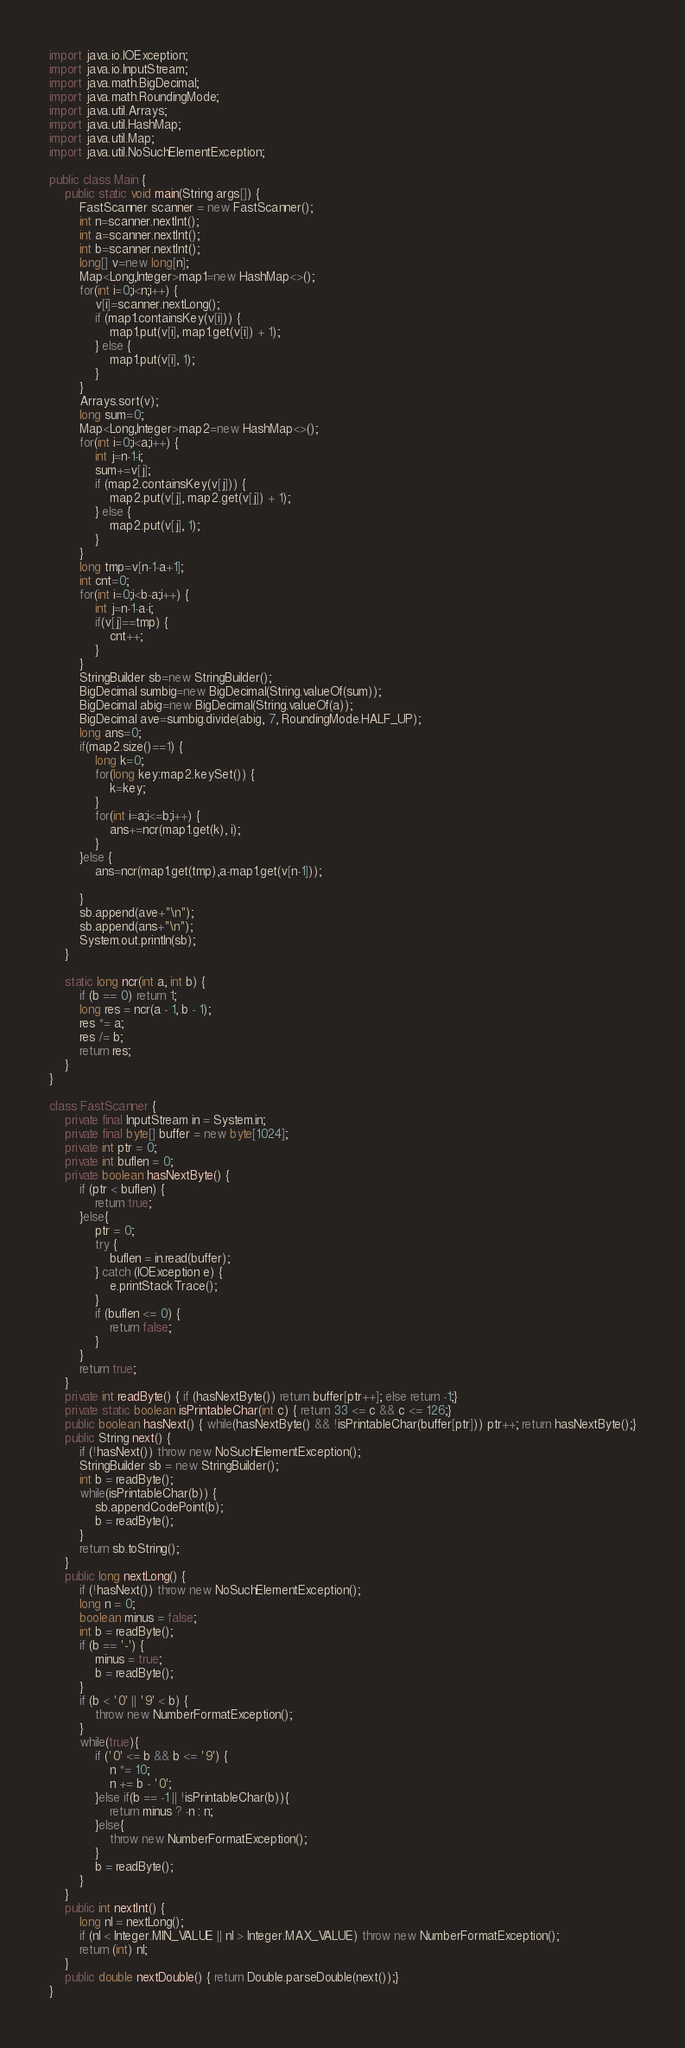<code> <loc_0><loc_0><loc_500><loc_500><_Java_>import java.io.IOException;
import java.io.InputStream;
import java.math.BigDecimal;
import java.math.RoundingMode;
import java.util.Arrays;
import java.util.HashMap;
import java.util.Map;
import java.util.NoSuchElementException;

public class Main {
	public static void main(String args[]) {
		FastScanner scanner = new FastScanner();
		int n=scanner.nextInt();
		int a=scanner.nextInt();
		int b=scanner.nextInt();
		long[] v=new long[n];
		Map<Long,Integer>map1=new HashMap<>();
		for(int i=0;i<n;i++) {
			v[i]=scanner.nextLong();
			if (map1.containsKey(v[i])) {
				map1.put(v[i], map1.get(v[i]) + 1);
			} else {
				map1.put(v[i], 1);
			}
		}
		Arrays.sort(v);
		long sum=0;
		Map<Long,Integer>map2=new HashMap<>();
		for(int i=0;i<a;i++) {
			int j=n-1-i;
			sum+=v[j];
			if (map2.containsKey(v[j])) {
				map2.put(v[j], map2.get(v[j]) + 1);
			} else {
				map2.put(v[j], 1);
			}
		}
		long tmp=v[n-1-a+1];
		int cnt=0;
		for(int i=0;i<b-a;i++) {
			int j=n-1-a-i;
			if(v[j]==tmp) {
				cnt++;
			}
		}
		StringBuilder sb=new StringBuilder();
		BigDecimal sumbig=new BigDecimal(String.valueOf(sum));
		BigDecimal abig=new BigDecimal(String.valueOf(a));
		BigDecimal ave=sumbig.divide(abig, 7, RoundingMode.HALF_UP);
		long ans=0;
		if(map2.size()==1) {
			long k=0;
			for(long key:map2.keySet()) {
				k=key;
			}
			for(int i=a;i<=b;i++) {
				ans+=ncr(map1.get(k), i);
			}
		}else {
			ans=ncr(map1.get(tmp),a-map1.get(v[n-1]));
			
		}
		sb.append(ave+"\n");
		sb.append(ans+"\n");
		System.out.println(sb);
	}

	static long ncr(int a, int b) {
		if (b == 0) return 1;
		long res = ncr(a - 1, b - 1);
		res *= a;
		res /= b;
		return res;
	}
}

class FastScanner {
    private final InputStream in = System.in;
    private final byte[] buffer = new byte[1024];
    private int ptr = 0;
    private int buflen = 0;
    private boolean hasNextByte() {
        if (ptr < buflen) {
            return true;
        }else{
            ptr = 0;
            try {
                buflen = in.read(buffer);
            } catch (IOException e) {
                e.printStackTrace();
            }
            if (buflen <= 0) {
                return false;
            }
        }
        return true;
    }
    private int readByte() { if (hasNextByte()) return buffer[ptr++]; else return -1;}
    private static boolean isPrintableChar(int c) { return 33 <= c && c <= 126;}
    public boolean hasNext() { while(hasNextByte() && !isPrintableChar(buffer[ptr])) ptr++; return hasNextByte();}
    public String next() {
        if (!hasNext()) throw new NoSuchElementException();
        StringBuilder sb = new StringBuilder();
        int b = readByte();
        while(isPrintableChar(b)) {
            sb.appendCodePoint(b);
            b = readByte();
        }
        return sb.toString();
    }
    public long nextLong() {
        if (!hasNext()) throw new NoSuchElementException();
        long n = 0;
        boolean minus = false;
        int b = readByte();
        if (b == '-') {
            minus = true;
            b = readByte();
        }
        if (b < '0' || '9' < b) {
            throw new NumberFormatException();
        }
        while(true){
            if ('0' <= b && b <= '9') {
                n *= 10;
                n += b - '0';
            }else if(b == -1 || !isPrintableChar(b)){
                return minus ? -n : n;
            }else{
                throw new NumberFormatException();
            }
            b = readByte();
        }
    }
    public int nextInt() {
        long nl = nextLong();
        if (nl < Integer.MIN_VALUE || nl > Integer.MAX_VALUE) throw new NumberFormatException();
        return (int) nl;
    }
    public double nextDouble() { return Double.parseDouble(next());}
}
</code> 